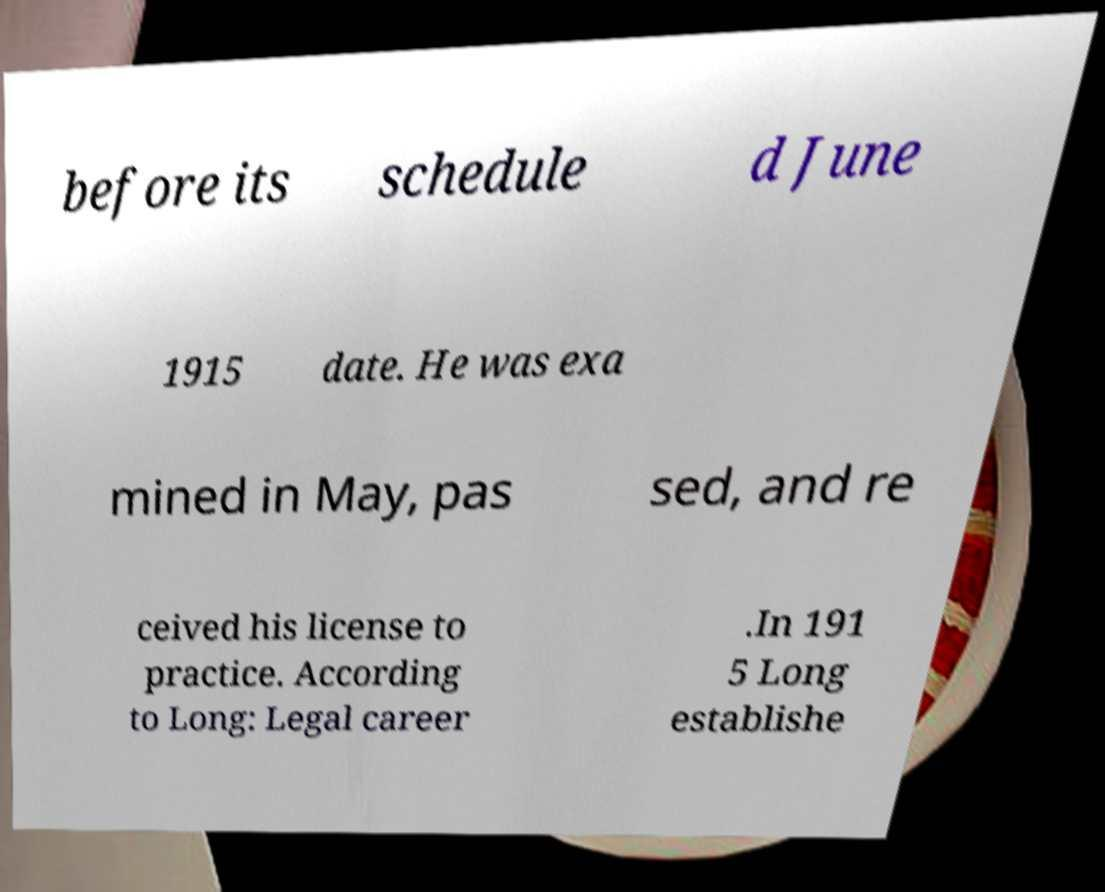Could you extract and type out the text from this image? before its schedule d June 1915 date. He was exa mined in May, pas sed, and re ceived his license to practice. According to Long: Legal career .In 191 5 Long establishe 